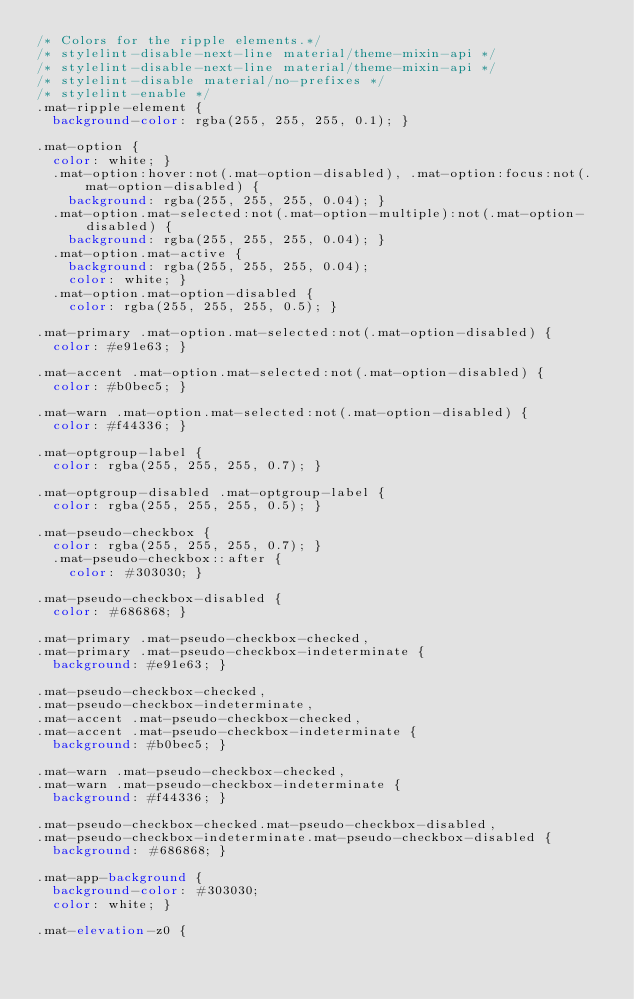Convert code to text. <code><loc_0><loc_0><loc_500><loc_500><_CSS_>/* Colors for the ripple elements.*/
/* stylelint-disable-next-line material/theme-mixin-api */
/* stylelint-disable-next-line material/theme-mixin-api */
/* stylelint-disable material/no-prefixes */
/* stylelint-enable */
.mat-ripple-element {
  background-color: rgba(255, 255, 255, 0.1); }

.mat-option {
  color: white; }
  .mat-option:hover:not(.mat-option-disabled), .mat-option:focus:not(.mat-option-disabled) {
    background: rgba(255, 255, 255, 0.04); }
  .mat-option.mat-selected:not(.mat-option-multiple):not(.mat-option-disabled) {
    background: rgba(255, 255, 255, 0.04); }
  .mat-option.mat-active {
    background: rgba(255, 255, 255, 0.04);
    color: white; }
  .mat-option.mat-option-disabled {
    color: rgba(255, 255, 255, 0.5); }

.mat-primary .mat-option.mat-selected:not(.mat-option-disabled) {
  color: #e91e63; }

.mat-accent .mat-option.mat-selected:not(.mat-option-disabled) {
  color: #b0bec5; }

.mat-warn .mat-option.mat-selected:not(.mat-option-disabled) {
  color: #f44336; }

.mat-optgroup-label {
  color: rgba(255, 255, 255, 0.7); }

.mat-optgroup-disabled .mat-optgroup-label {
  color: rgba(255, 255, 255, 0.5); }

.mat-pseudo-checkbox {
  color: rgba(255, 255, 255, 0.7); }
  .mat-pseudo-checkbox::after {
    color: #303030; }

.mat-pseudo-checkbox-disabled {
  color: #686868; }

.mat-primary .mat-pseudo-checkbox-checked,
.mat-primary .mat-pseudo-checkbox-indeterminate {
  background: #e91e63; }

.mat-pseudo-checkbox-checked,
.mat-pseudo-checkbox-indeterminate,
.mat-accent .mat-pseudo-checkbox-checked,
.mat-accent .mat-pseudo-checkbox-indeterminate {
  background: #b0bec5; }

.mat-warn .mat-pseudo-checkbox-checked,
.mat-warn .mat-pseudo-checkbox-indeterminate {
  background: #f44336; }

.mat-pseudo-checkbox-checked.mat-pseudo-checkbox-disabled,
.mat-pseudo-checkbox-indeterminate.mat-pseudo-checkbox-disabled {
  background: #686868; }

.mat-app-background {
  background-color: #303030;
  color: white; }

.mat-elevation-z0 {</code> 